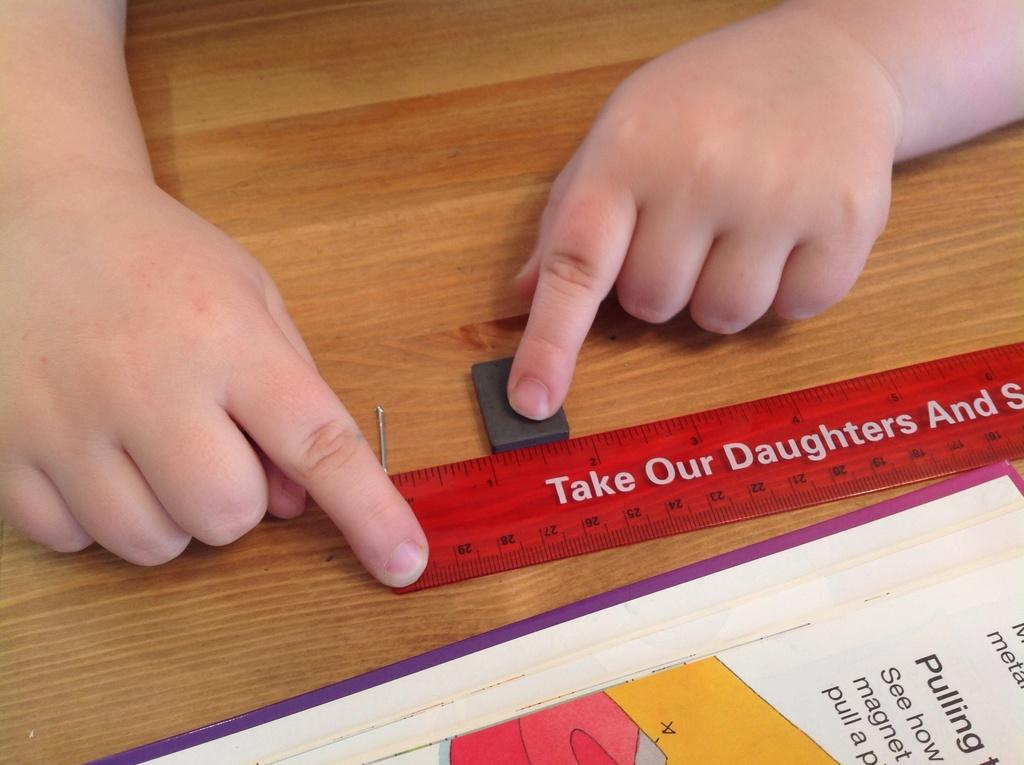<image>
Present a compact description of the photo's key features. childrens hands holding a ruler which reads take our daughters 